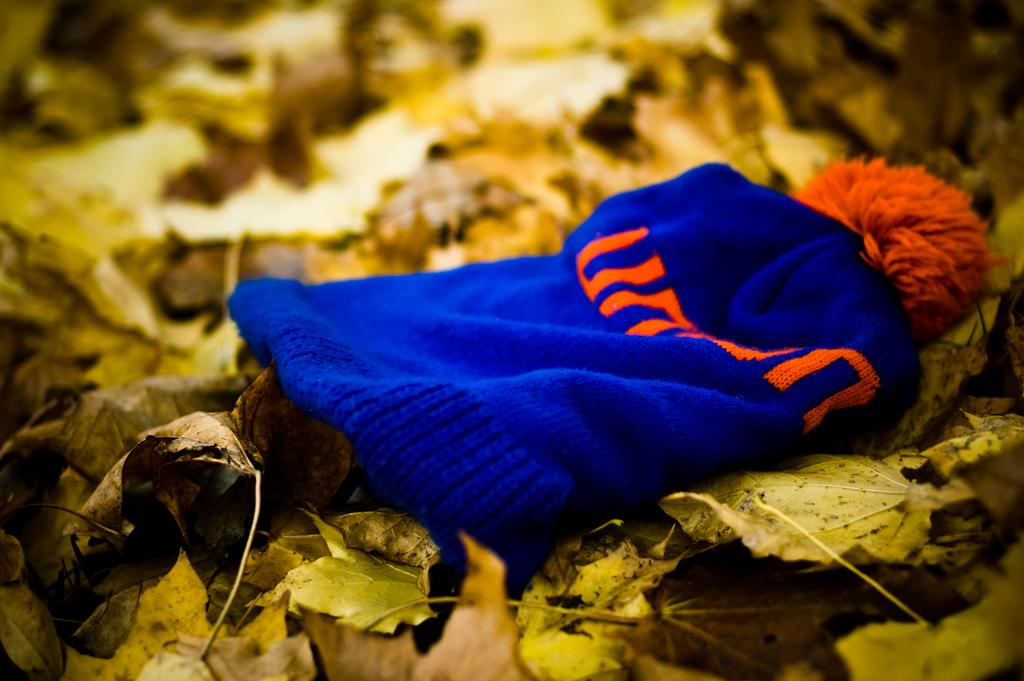What color is the cap in the image? The cap in the image is blue. Is there any text or writing on the cap? Yes, there is something written on the cap. What is the cap placed on in the image? The cap is on yellow leaves. Are there any other leaves visible in the image? Yes, there are other leaves beside the cap. What song is being played on the cord in the image? There is no cord or music playing in the image; it only features a blue cap on yellow leaves with other leaves nearby. 